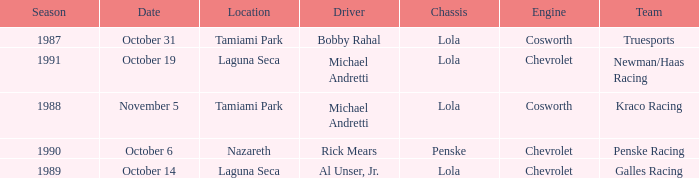On what date was the race at Nazareth? October 6. 